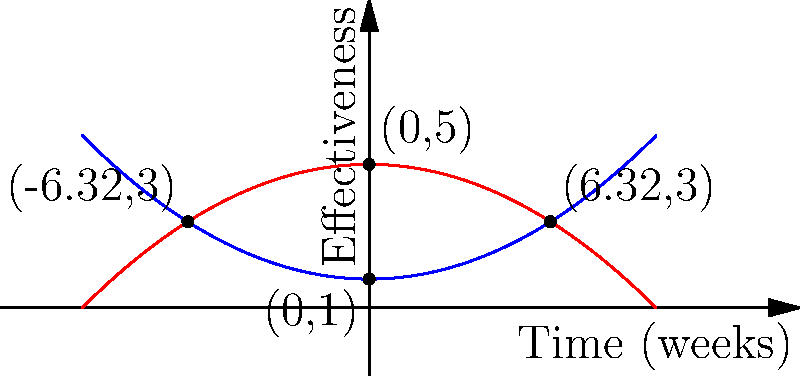Two governmental response strategies to an epidemic are modeled by the following equations:

Strategy A: $f(x) = 0.05x^2 + 1$
Strategy B: $g(x) = -0.05x^2 + 5$

Where $x$ represents time in weeks and $y$ represents the effectiveness of the strategy. At what points in time do these strategies have equal effectiveness, and what is that effectiveness level? To find the intersection points of these two curves, we need to solve the equation:

$f(x) = g(x)$

1) Substitute the functions:
   $0.05x^2 + 1 = -0.05x^2 + 5$

2) Rearrange the equation:
   $0.05x^2 + 0.05x^2 = 5 - 1$
   $0.1x^2 = 4$

3) Solve for $x$:
   $x^2 = 4 / 0.1 = 40$
   $x = \pm \sqrt{40} = \pm 6.32$

4) The intersection points occur at $x = -6.32$ and $x = 6.32$

5) To find the effectiveness level at these points, substitute either $x$ value into either function:
   $f(6.32) = 0.05(6.32)^2 + 1 = 0.05(40) + 1 = 3$

Therefore, the strategies have equal effectiveness at 6.32 weeks before and after the start point, with an effectiveness level of 3.
Answer: (-6.32, 3) and (6.32, 3) 